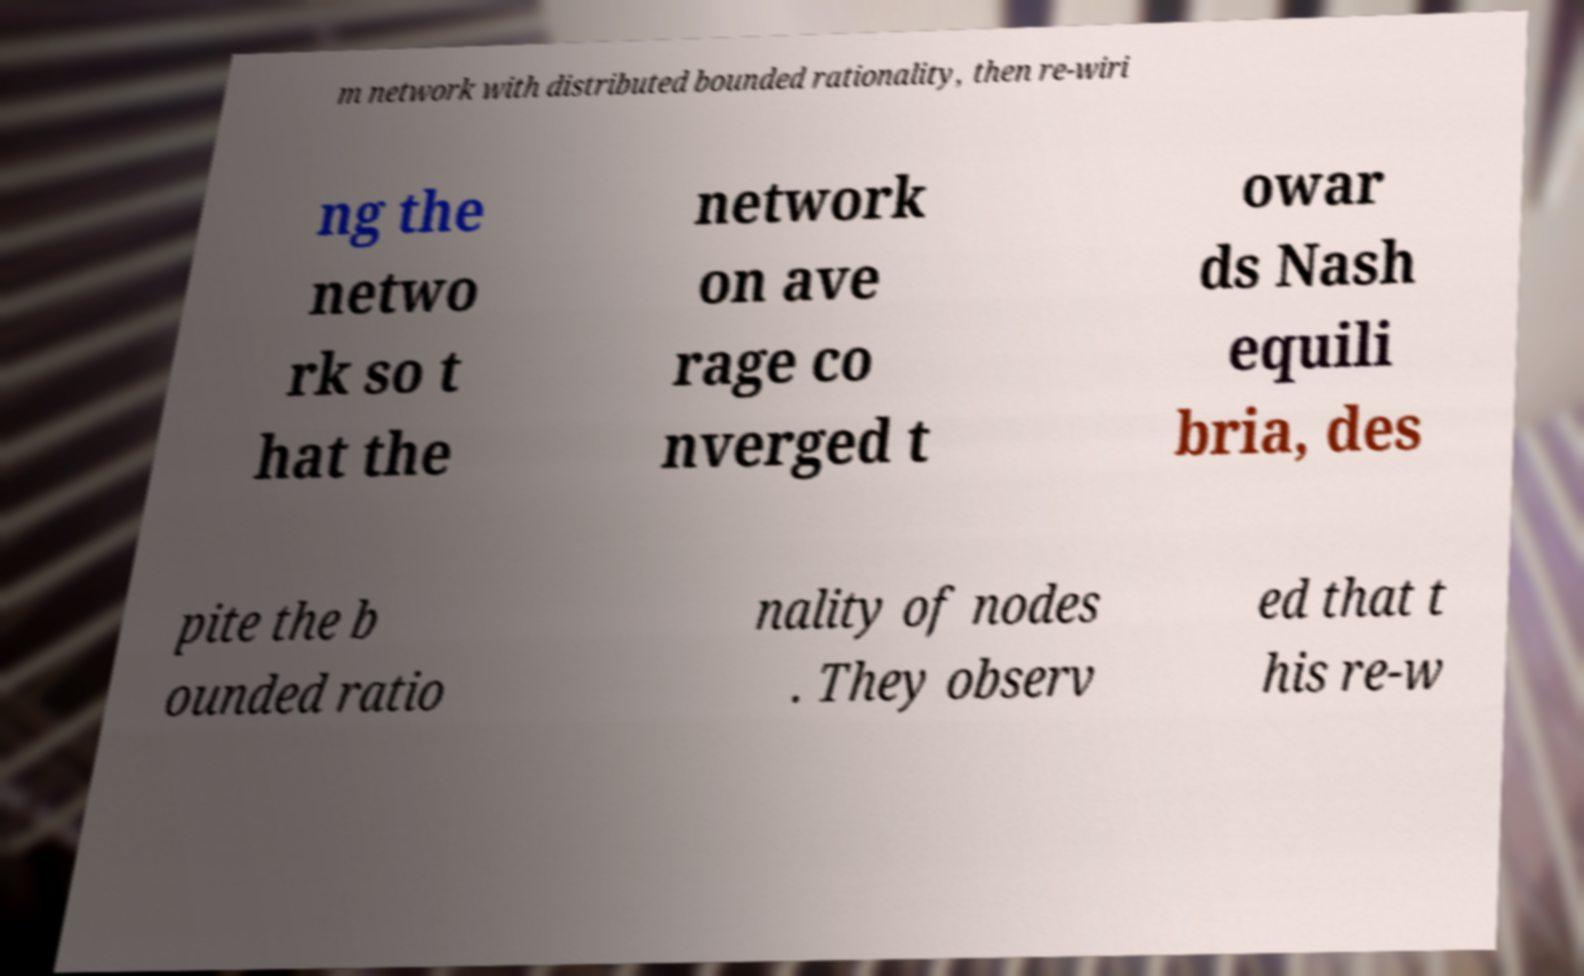Can you read and provide the text displayed in the image?This photo seems to have some interesting text. Can you extract and type it out for me? m network with distributed bounded rationality, then re-wiri ng the netwo rk so t hat the network on ave rage co nverged t owar ds Nash equili bria, des pite the b ounded ratio nality of nodes . They observ ed that t his re-w 